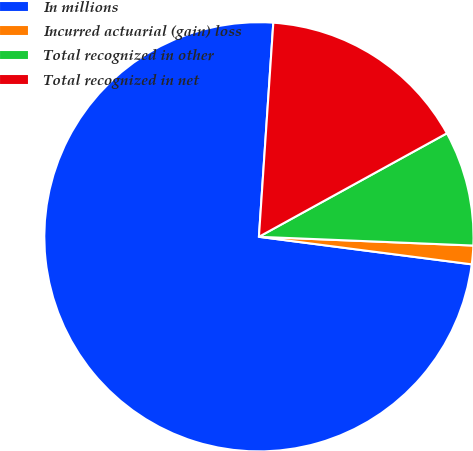Convert chart to OTSL. <chart><loc_0><loc_0><loc_500><loc_500><pie_chart><fcel>In millions<fcel>Incurred actuarial (gain) loss<fcel>Total recognized in other<fcel>Total recognized in net<nl><fcel>74.02%<fcel>1.4%<fcel>8.66%<fcel>15.92%<nl></chart> 